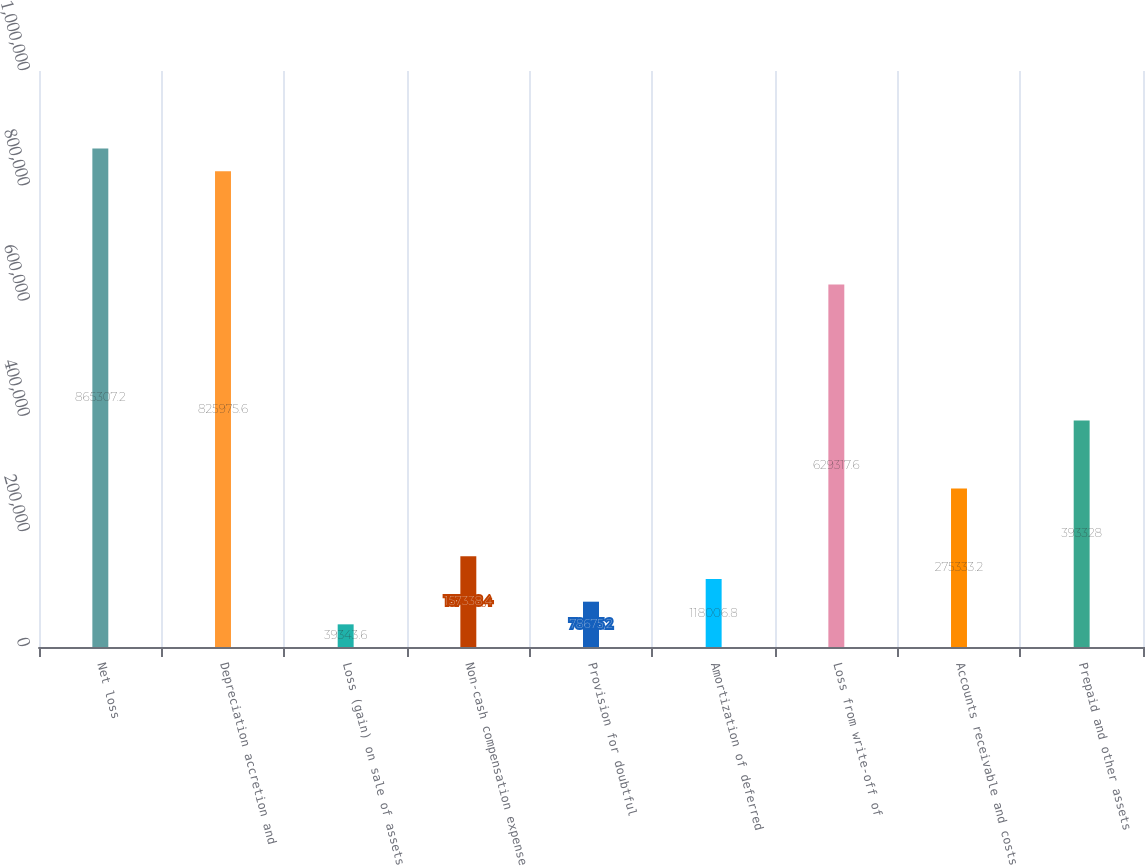Convert chart to OTSL. <chart><loc_0><loc_0><loc_500><loc_500><bar_chart><fcel>Net loss<fcel>Depreciation accretion and<fcel>Loss (gain) on sale of assets<fcel>Non-cash compensation expense<fcel>Provision for doubtful<fcel>Amortization of deferred<fcel>Loss from write-off of<fcel>Accounts receivable and costs<fcel>Prepaid and other assets<nl><fcel>865307<fcel>825976<fcel>39343.6<fcel>157338<fcel>78675.2<fcel>118007<fcel>629318<fcel>275333<fcel>393328<nl></chart> 